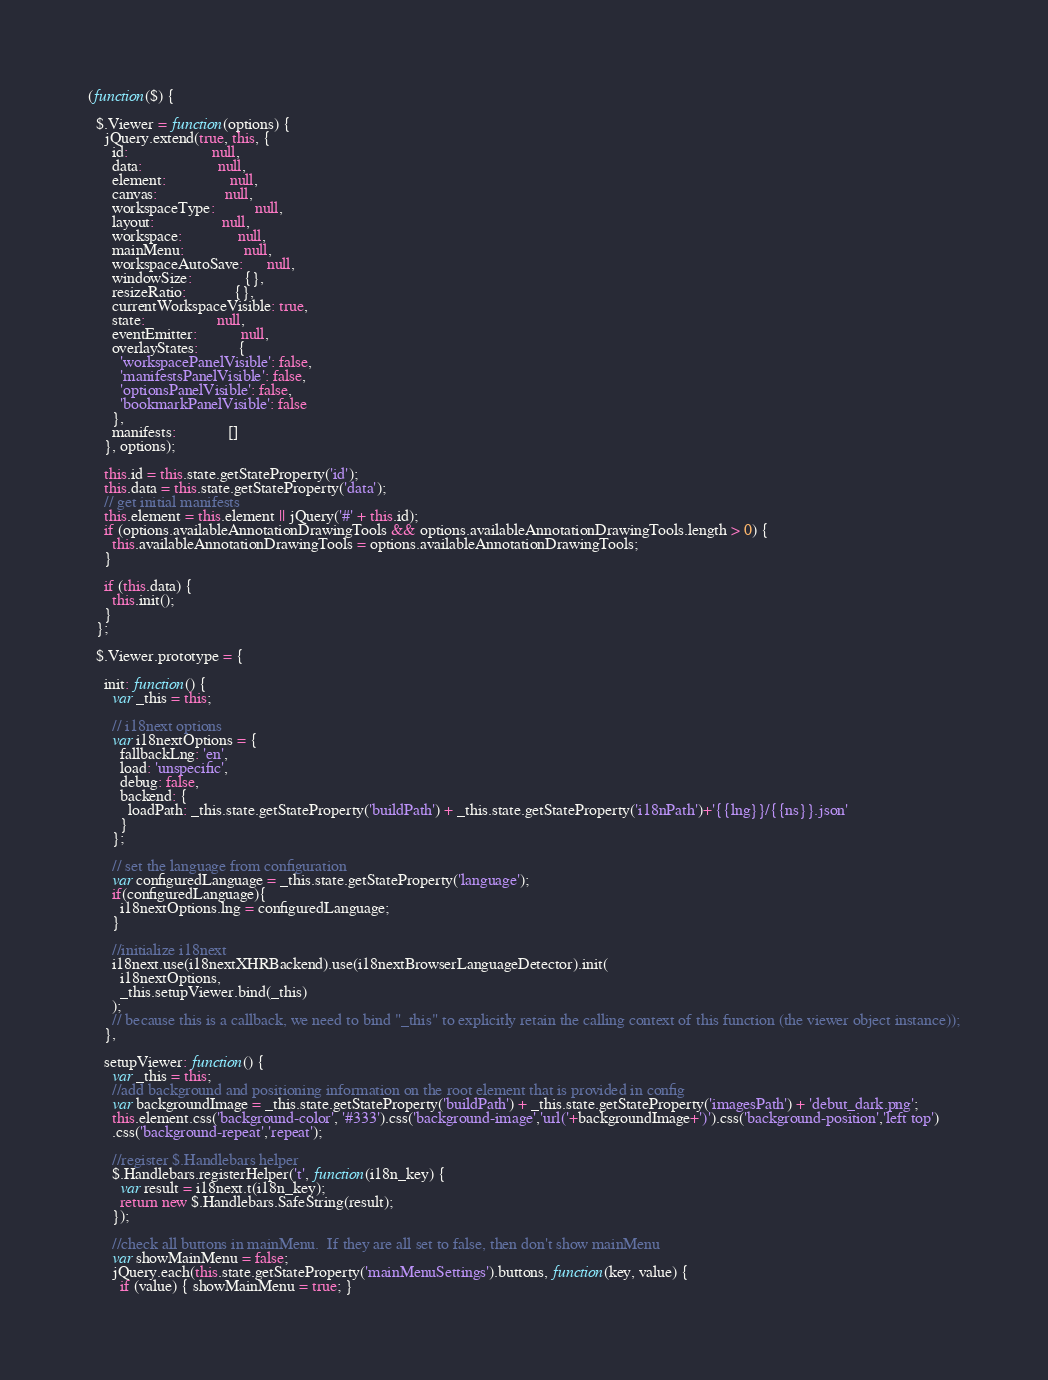<code> <loc_0><loc_0><loc_500><loc_500><_JavaScript_>(function($) {

  $.Viewer = function(options) {
    jQuery.extend(true, this, {
      id:                     null,
      data:                   null,
      element:                null,
      canvas:                 null,
      workspaceType:          null,
      layout:                 null,
      workspace:              null,
      mainMenu:               null,
      workspaceAutoSave:      null,
      windowSize:             {},
      resizeRatio:            {},
      currentWorkspaceVisible: true,
      state:                  null,
      eventEmitter:           null,
      overlayStates:          {
        'workspacePanelVisible': false,
        'manifestsPanelVisible': false,
        'optionsPanelVisible': false,
        'bookmarkPanelVisible': false
      },
      manifests:             []
    }, options);

    this.id = this.state.getStateProperty('id');
    this.data = this.state.getStateProperty('data');
    // get initial manifests
    this.element = this.element || jQuery('#' + this.id);
    if (options.availableAnnotationDrawingTools && options.availableAnnotationDrawingTools.length > 0) {
      this.availableAnnotationDrawingTools = options.availableAnnotationDrawingTools;
    }

    if (this.data) {
      this.init();
    }
  };

  $.Viewer.prototype = {

    init: function() {
      var _this = this;

      // i18next options
      var i18nextOptions = {
        fallbackLng: 'en',
        load: 'unspecific',
        debug: false,
        backend: {
          loadPath: _this.state.getStateProperty('buildPath') + _this.state.getStateProperty('i18nPath')+'{{lng}}/{{ns}}.json'
        }
      };

      // set the language from configuration
      var configuredLanguage = _this.state.getStateProperty('language');
      if(configuredLanguage){
        i18nextOptions.lng = configuredLanguage;
      }

      //initialize i18next
      i18next.use(i18nextXHRBackend).use(i18nextBrowserLanguageDetector).init(
        i18nextOptions,
        _this.setupViewer.bind(_this)
      );
      // because this is a callback, we need to bind "_this" to explicitly retain the calling context of this function (the viewer object instance));
    },

    setupViewer: function() {
      var _this = this;
      //add background and positioning information on the root element that is provided in config
      var backgroundImage = _this.state.getStateProperty('buildPath') + _this.state.getStateProperty('imagesPath') + 'debut_dark.png';
      this.element.css('background-color', '#333').css('background-image','url('+backgroundImage+')').css('background-position','left top')
      .css('background-repeat','repeat');

      //register $.Handlebars helper
      $.Handlebars.registerHelper('t', function(i18n_key) {
        var result = i18next.t(i18n_key);
        return new $.Handlebars.SafeString(result);
      });

      //check all buttons in mainMenu.  If they are all set to false, then don't show mainMenu
      var showMainMenu = false;
      jQuery.each(this.state.getStateProperty('mainMenuSettings').buttons, function(key, value) {
        if (value) { showMainMenu = true; }</code> 